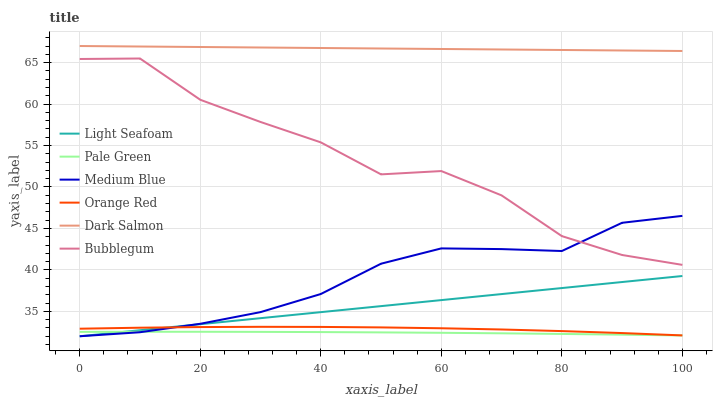Does Bubblegum have the minimum area under the curve?
Answer yes or no. No. Does Bubblegum have the maximum area under the curve?
Answer yes or no. No. Is Bubblegum the smoothest?
Answer yes or no. No. Is Dark Salmon the roughest?
Answer yes or no. No. Does Bubblegum have the lowest value?
Answer yes or no. No. Does Bubblegum have the highest value?
Answer yes or no. No. Is Bubblegum less than Dark Salmon?
Answer yes or no. Yes. Is Dark Salmon greater than Pale Green?
Answer yes or no. Yes. Does Bubblegum intersect Dark Salmon?
Answer yes or no. No. 